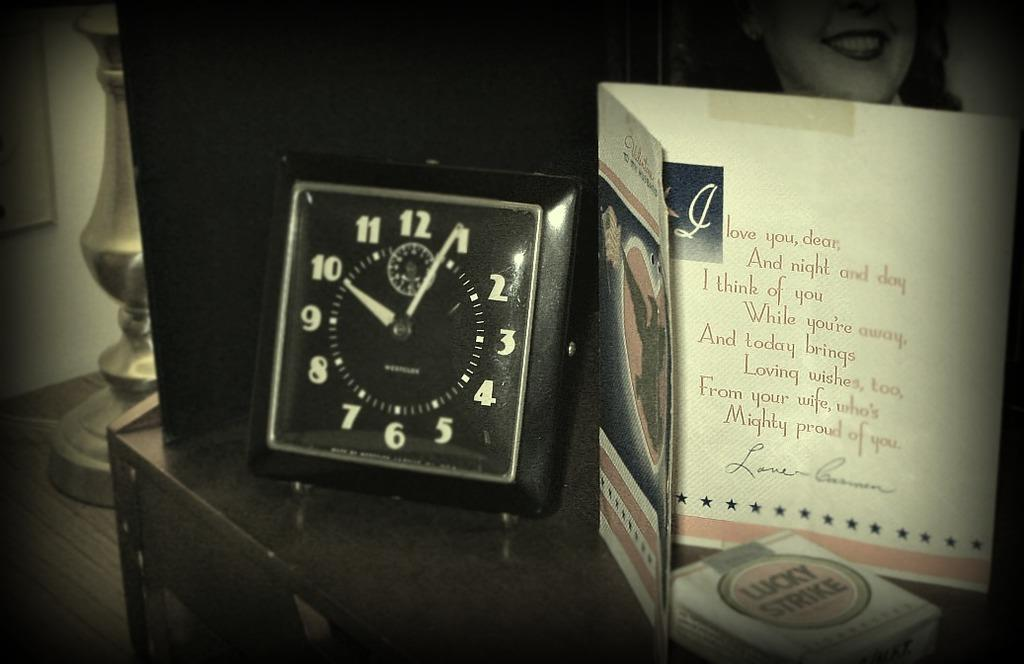<image>
Share a concise interpretation of the image provided. The card next to the clock starts of with, "I love you, dear." 